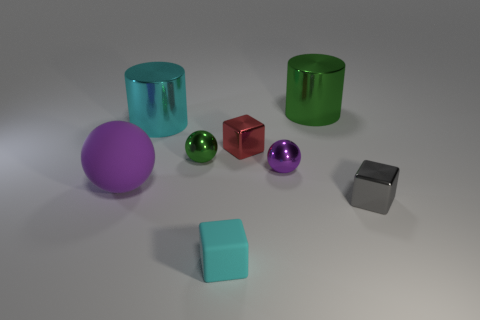Subtract all tiny red shiny cubes. How many cubes are left? 2 Subtract 1 gray cubes. How many objects are left? 7 Subtract all cylinders. How many objects are left? 6 Subtract 3 cubes. How many cubes are left? 0 Subtract all brown balls. Subtract all blue cylinders. How many balls are left? 3 Subtract all cyan blocks. How many yellow cylinders are left? 0 Subtract all cubes. Subtract all big purple balls. How many objects are left? 4 Add 4 cyan blocks. How many cyan blocks are left? 5 Add 6 cyan metal cylinders. How many cyan metal cylinders exist? 7 Add 2 large metal balls. How many objects exist? 10 